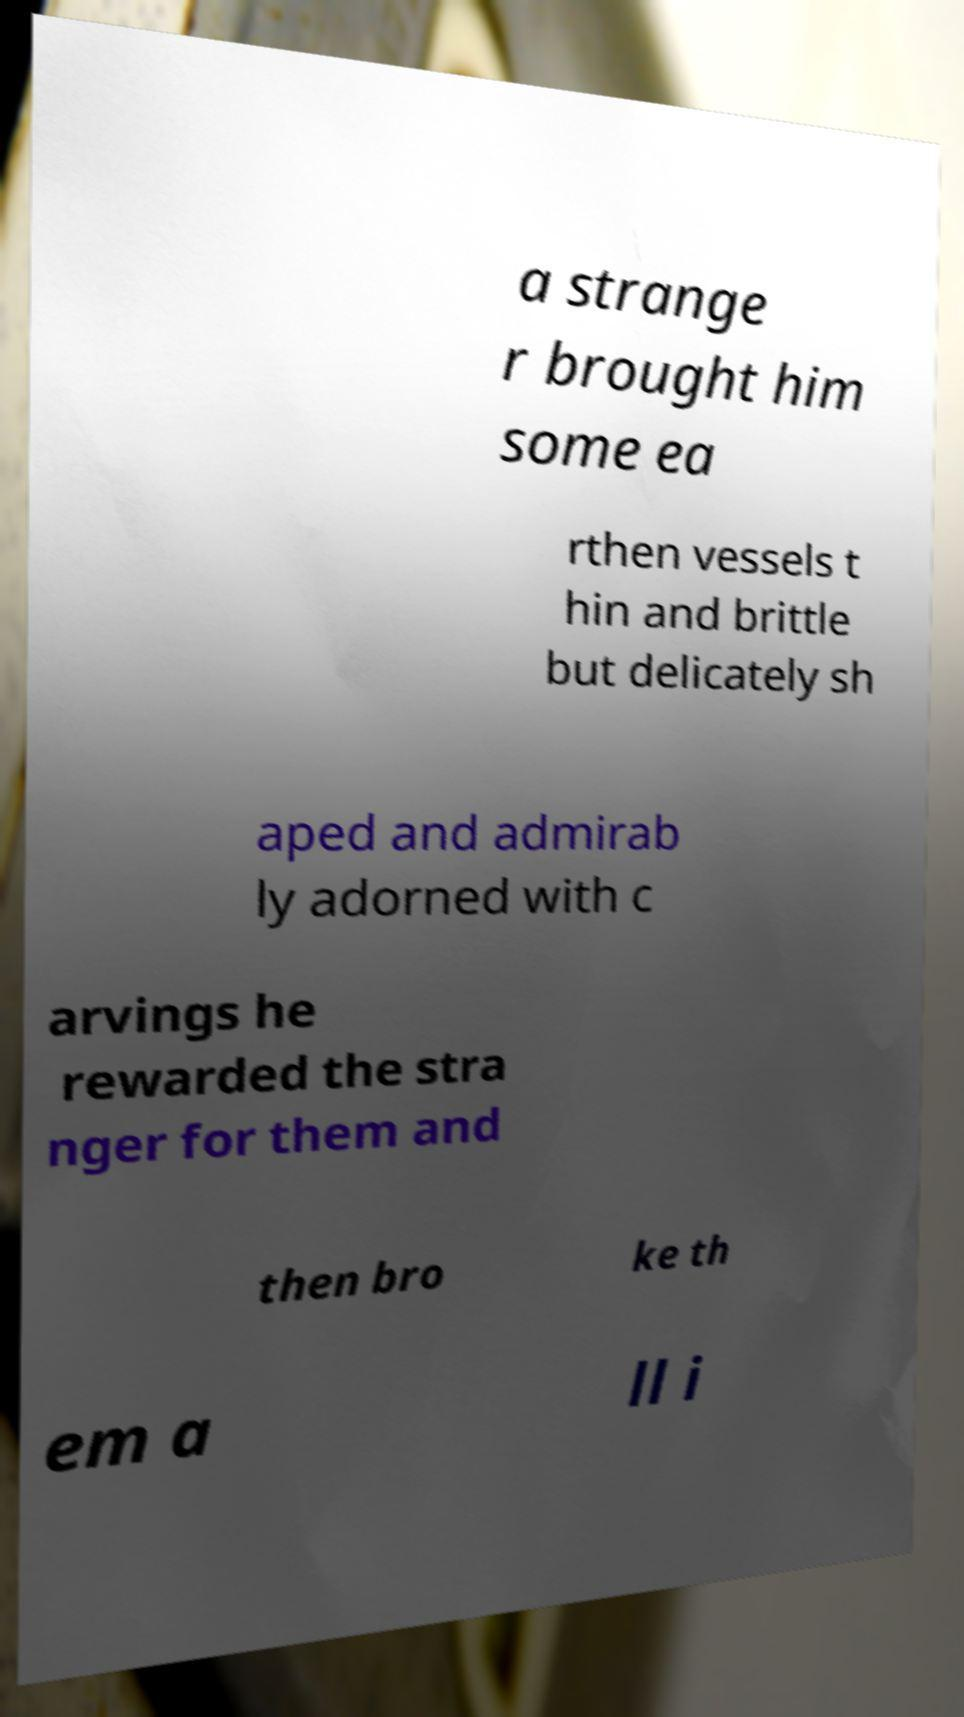Could you extract and type out the text from this image? a strange r brought him some ea rthen vessels t hin and brittle but delicately sh aped and admirab ly adorned with c arvings he rewarded the stra nger for them and then bro ke th em a ll i 